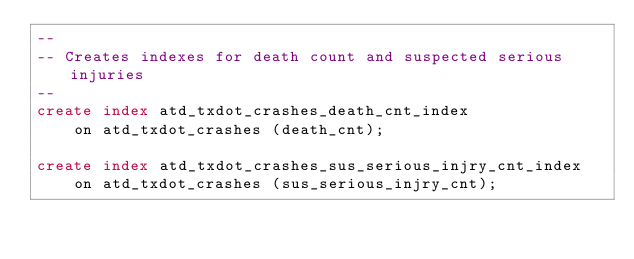Convert code to text. <code><loc_0><loc_0><loc_500><loc_500><_SQL_>--
-- Creates indexes for death count and suspected serious injuries
--
create index atd_txdot_crashes_death_cnt_index
	on atd_txdot_crashes (death_cnt);

create index atd_txdot_crashes_sus_serious_injry_cnt_index
	on atd_txdot_crashes (sus_serious_injry_cnt);
</code> 